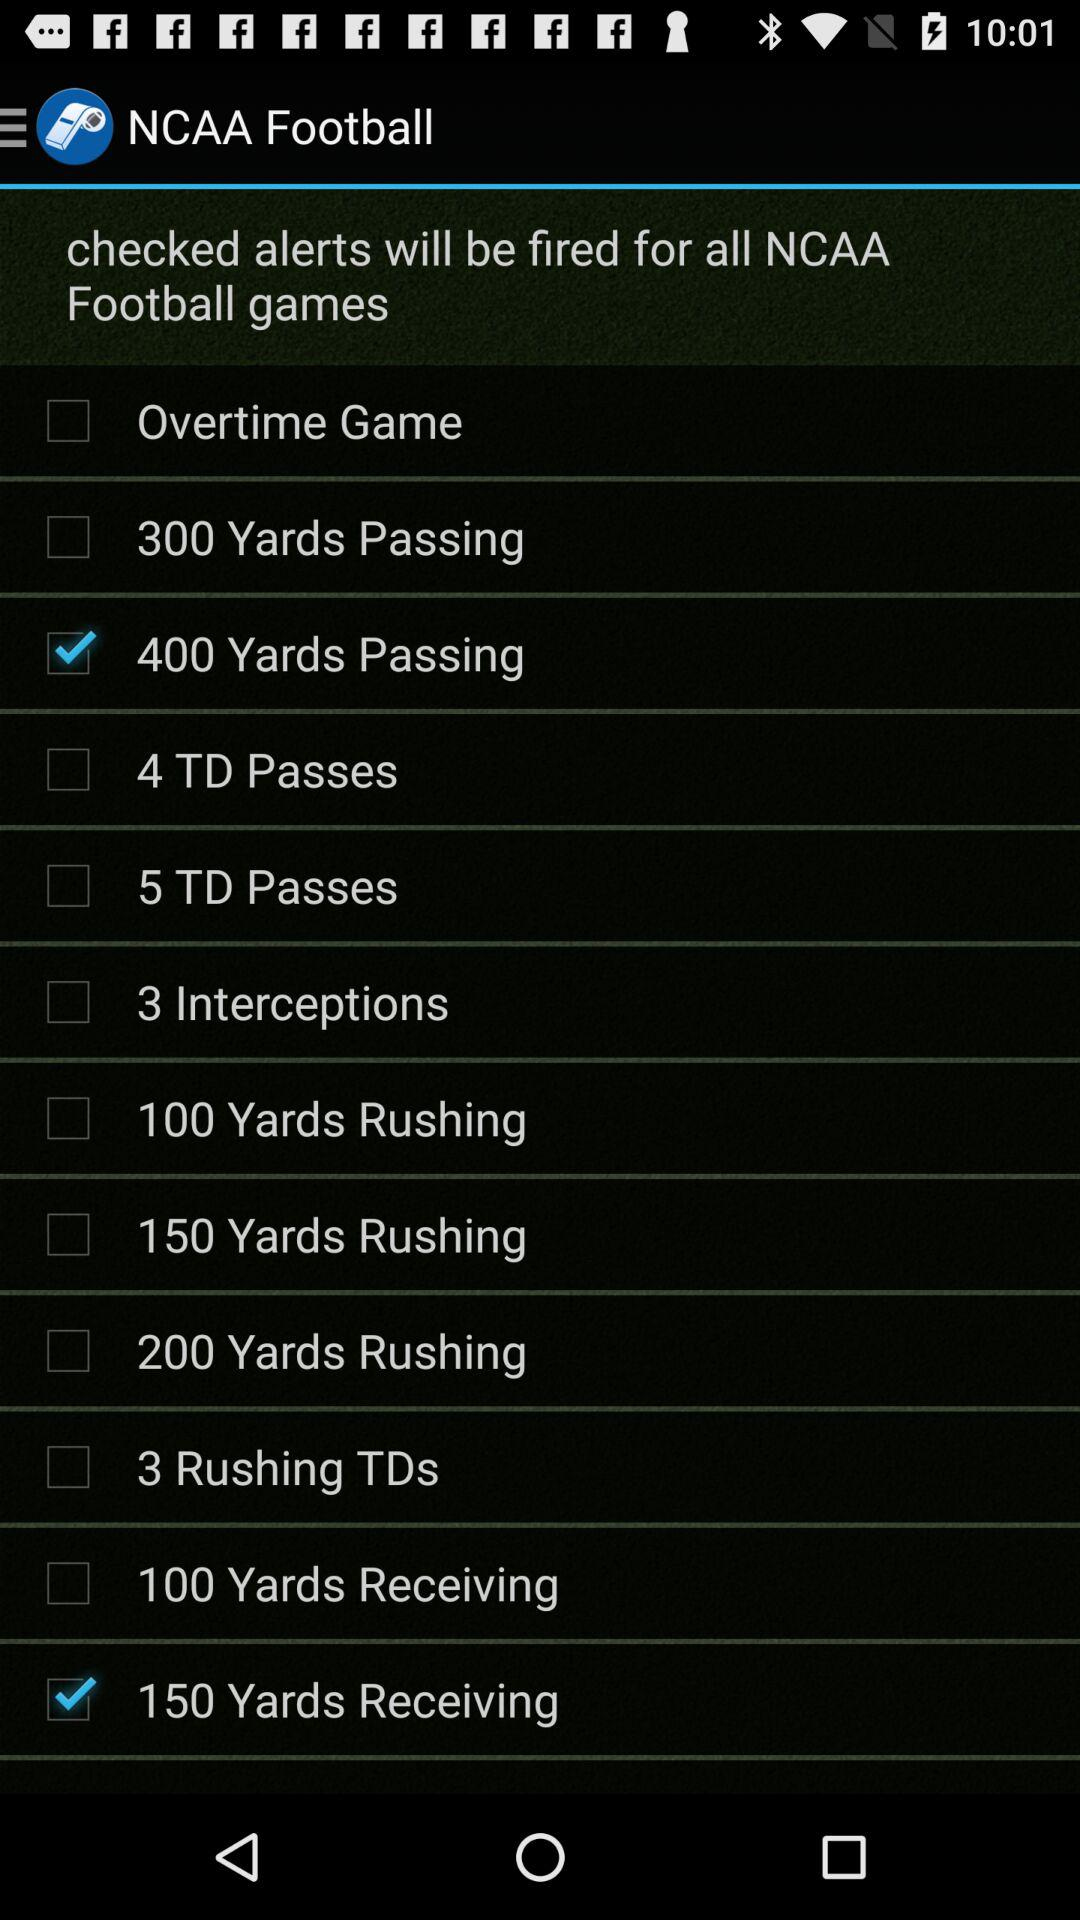How many more rushing touchdown alerts are there than interceptions alerts?
Answer the question using a single word or phrase. 2 